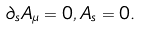Convert formula to latex. <formula><loc_0><loc_0><loc_500><loc_500>\partial _ { s } A _ { \mu } = 0 , A _ { s } = 0 .</formula> 